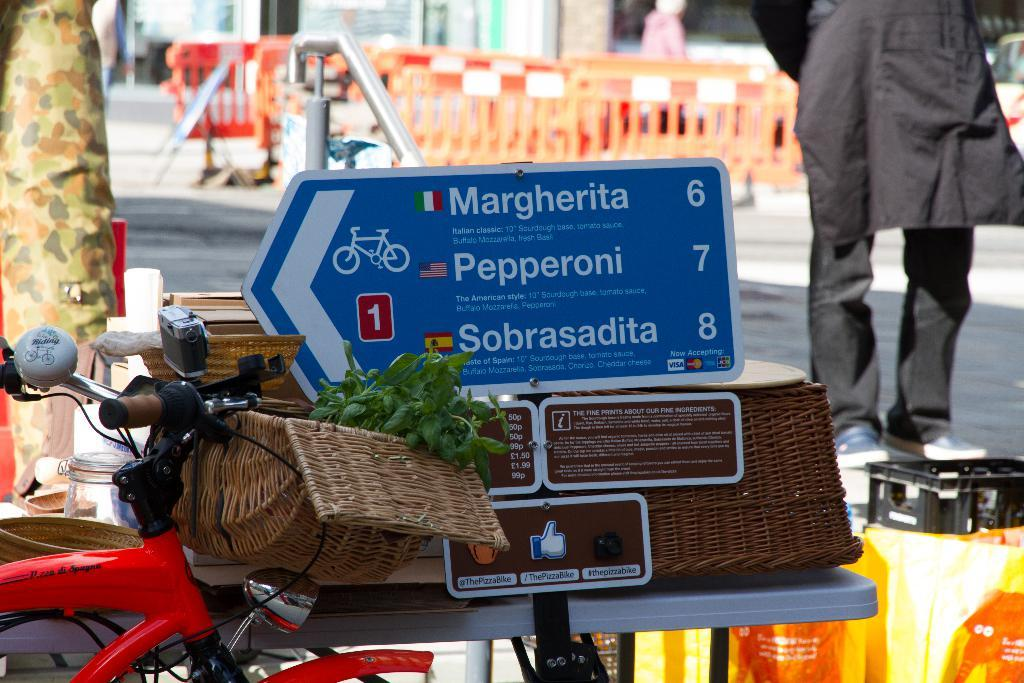What type of vehicle is in the image? There is a red bicycle in the image. What is the color of the board in the image? The board in the image is blue. Can you describe the person in the background of the image? The person in the background is wearing a black dress. What architectural feature can be seen in the background of the image? There are glass doors visible in the background of the image. How many cats are sitting on the blue color board in the image? There are no cats present in the image. What type of metal is used to construct the bicycle in the image? The facts provided do not mention the material used to construct the bicycle. 